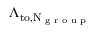Convert formula to latex. <formula><loc_0><loc_0><loc_500><loc_500>\Lambda _ { t o , N _ { g r o u p } }</formula> 